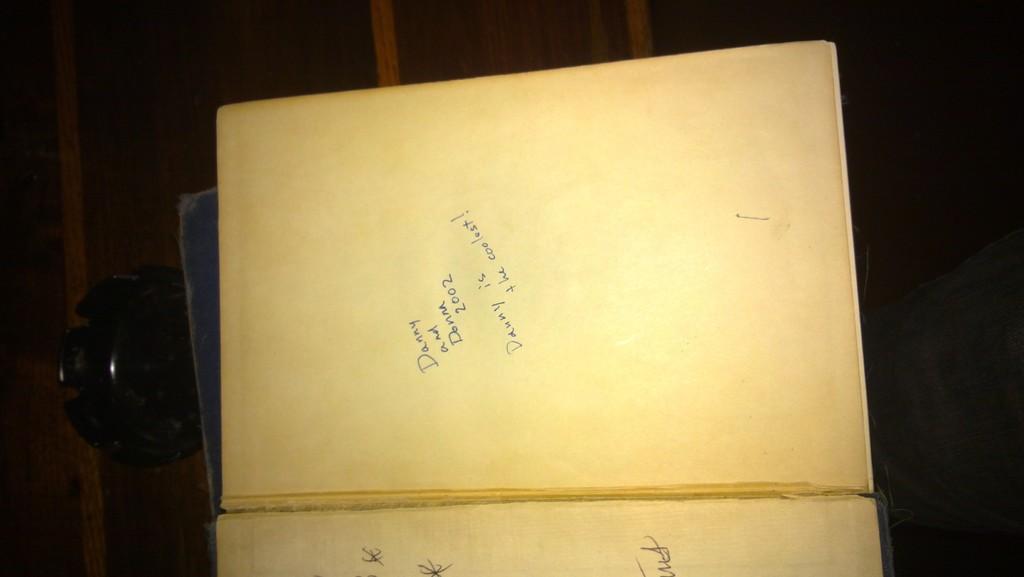Could you give a brief overview of what you see in this image? In front of the image there are books with some text on it. Beside the books there is some object on the table. On the right side of the image we can see the leg of a person. 